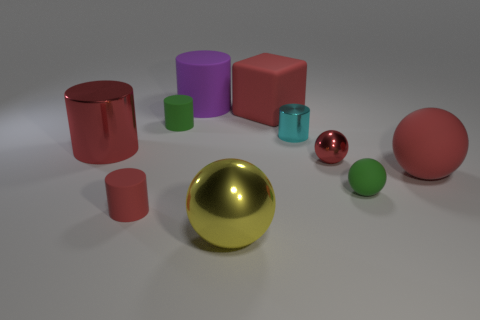Subtract 2 cylinders. How many cylinders are left? 3 Subtract all purple cylinders. How many cylinders are left? 4 Subtract all big red cylinders. How many cylinders are left? 4 Subtract all brown cylinders. Subtract all yellow balls. How many cylinders are left? 5 Subtract all spheres. How many objects are left? 6 Subtract 0 purple spheres. How many objects are left? 10 Subtract all yellow matte cylinders. Subtract all big purple rubber cylinders. How many objects are left? 9 Add 7 small rubber spheres. How many small rubber spheres are left? 8 Add 5 small green blocks. How many small green blocks exist? 5 